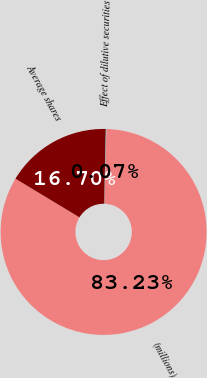<chart> <loc_0><loc_0><loc_500><loc_500><pie_chart><fcel>(millions)<fcel>Average shares<fcel>Effect of dilutive securities<nl><fcel>83.23%<fcel>16.7%<fcel>0.07%<nl></chart> 